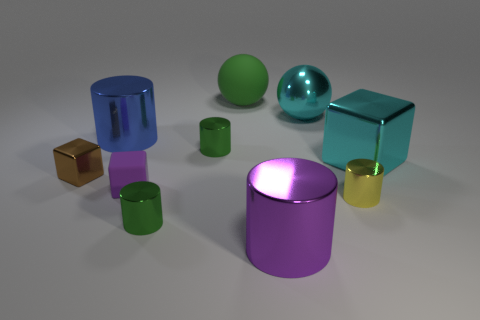Can you describe the shapes and colors present in this image? Certainly! The image displays a collection of geometric shapes with a glossy finish, including cylinders, cubes, and spheres. The colors are quite vibrant and vary from green, blue, purple, to gold and turquoise, which creates a visually appealing contrast. 